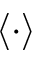<formula> <loc_0><loc_0><loc_500><loc_500>\langle \cdot \rangle</formula> 